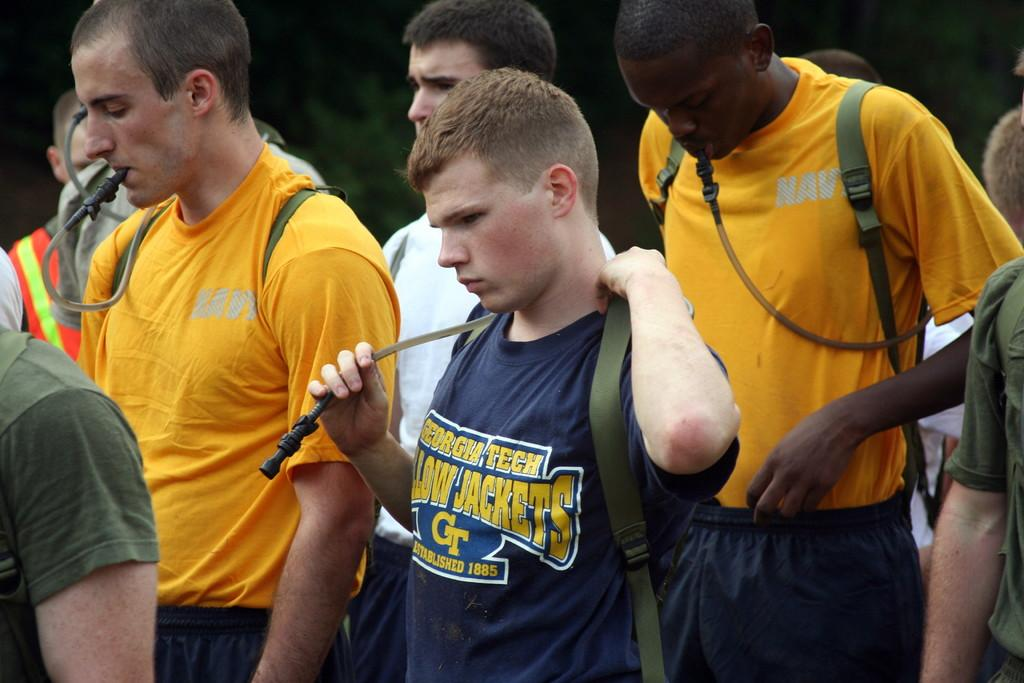What is happening in the foreground of the image? There is a group of people in the foreground of the image. What are some of the people in the group doing? Some of the people are standing. What are the people wearing that are visible in the image? Some people in the group are wearing bags. What can be seen in the background of the image? There are trees in the background of the image. What type of box can be heard making noise in the image? There is no box present in the image, and therefore no noise can be heard from it. 